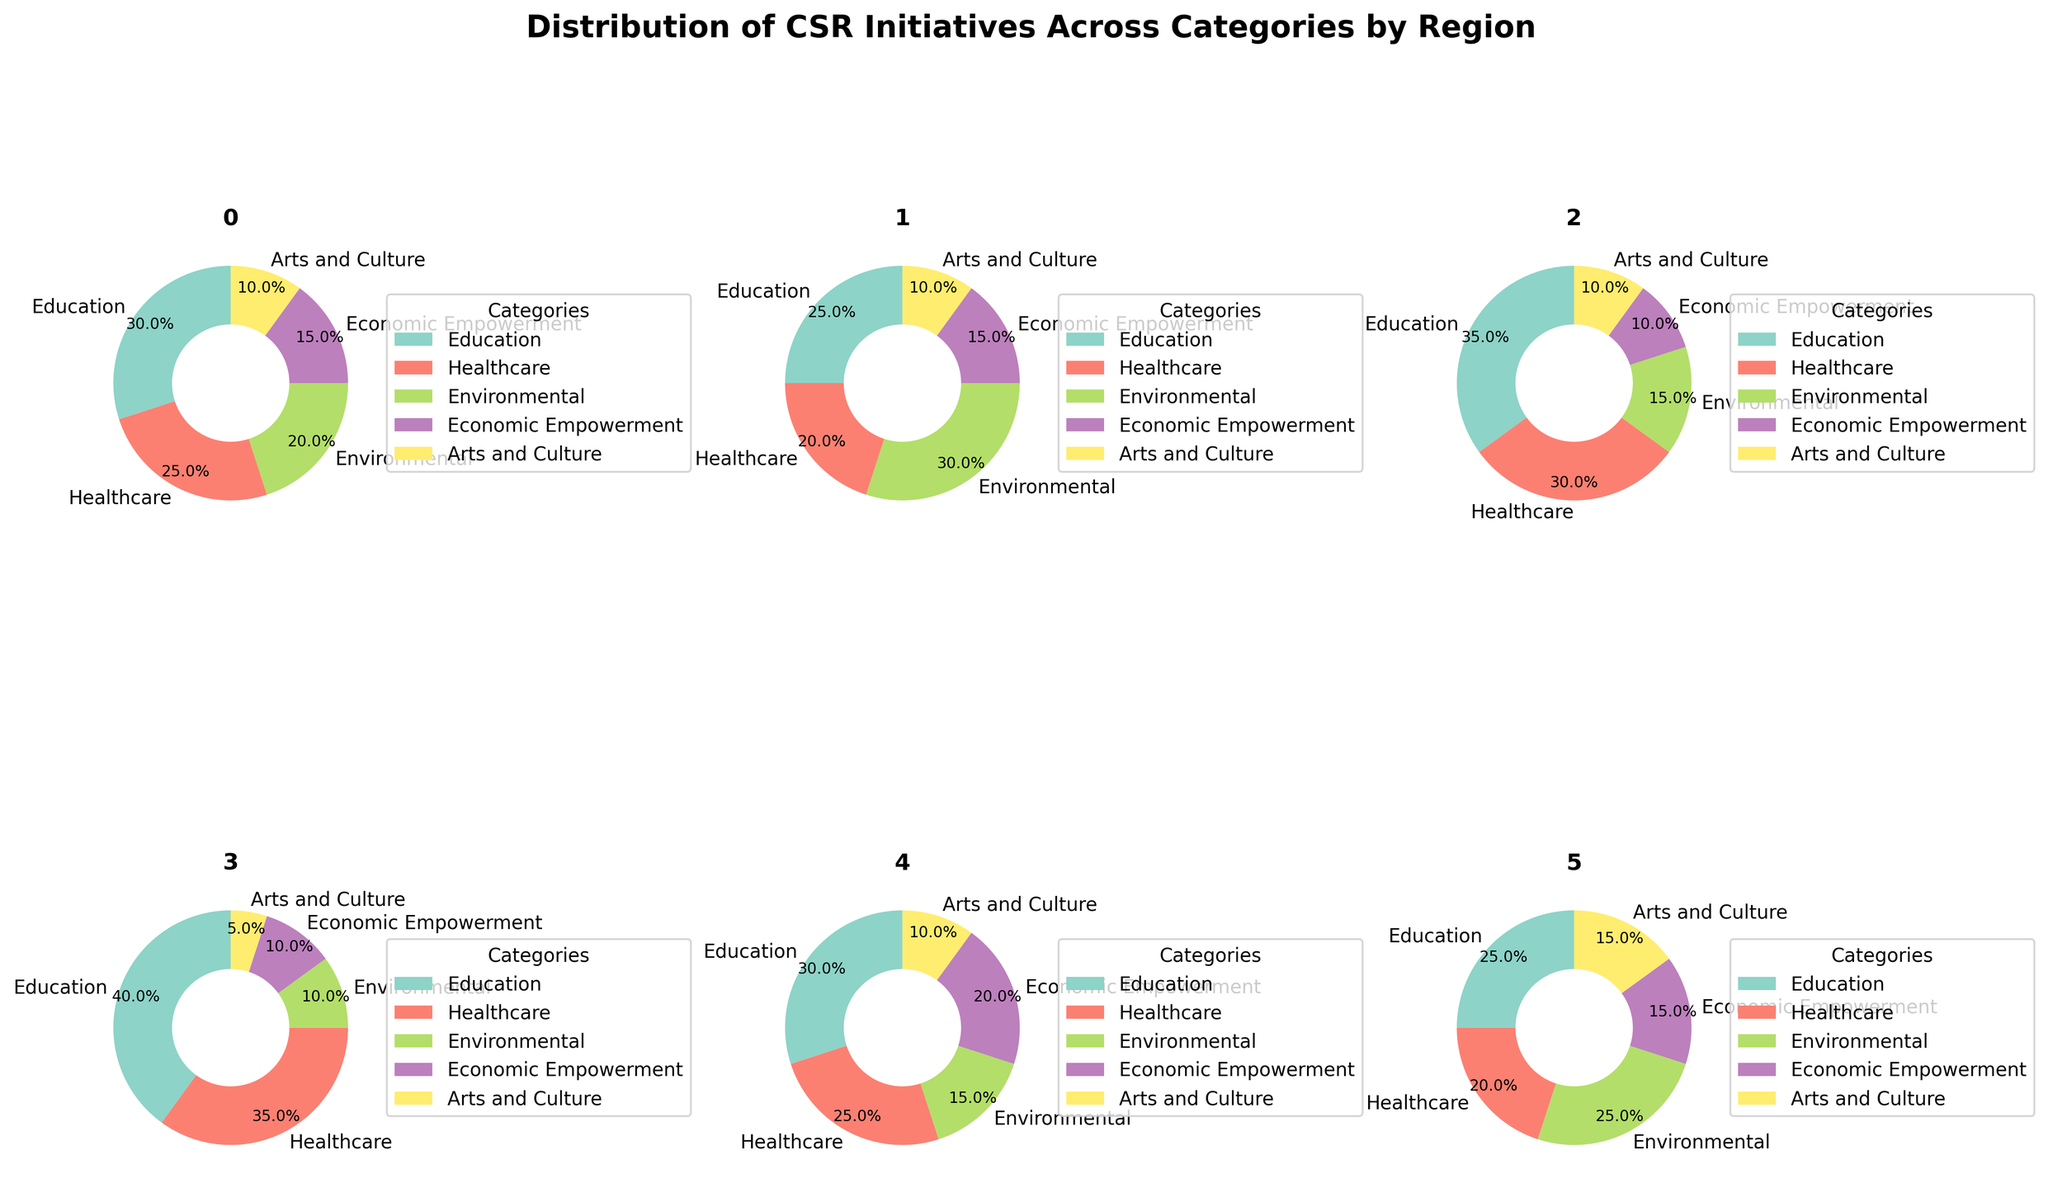How many regions are displayed in the figure? Count the total number of pie charts in the subplot. Each pie chart represents one region.
Answer: 6 Which region has the highest percentage of initiatives in healthcare? Look at each pie chart and identify the segment representing "Healthcare". Compare the percent values displayed in these segments across all regions.
Answer: Africa Which community support category receives the least focus in North America? Examine the North America pie chart and look for the smallest segment by percentage.
Answer: Arts and Culture In which region is "Environmental" support the highest? For each region, check the size of the "Environmental" segment and compare the percentages.
Answer: Europe What is the combined percentage of Education and Healthcare initiatives in Asia? Identify the percentages for Education and Healthcare on the Asia pie chart and add them together. 35% (Education) + 30% (Healthcare) = 65%
Answer: 65% Compare the support for "Economic Empowerment" in South America vs. Oceania. Which region provides more support? Look at the segments representing "Economic Empowerment" on the pie charts for South America and Oceania and compare their percentages.
Answer: South America What percentage of initiatives in Europe is dedicated to "Arts and Culture"? Find the "Arts and Culture" segment in the Europe pie chart and note the percentage.
Answer: 10% What is the difference in percentage points for "Education" initiatives between Africa and Oceania? Identify the percentages for "Education" in both Africa and Oceania and subtract the smaller value from the larger one. 40% (Africa) - 25% (Oceania) = 15 percentage points
Answer: 15 percentage points In which region is "Economic Empowerment" the least prioritized category? Check each regional pie chart and identify the smallest segment for "Economic Empowerment". Compare their percentages to find the smallest.
Answer: Asia (tied with Africa) Which region shows the most balanced distribution across all categories? Evaluate the pie charts and look for the region where the segment sizes are most similar to each other.
Answer: Oceania 